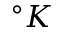Convert formula to latex. <formula><loc_0><loc_0><loc_500><loc_500>^ { \circ } K</formula> 